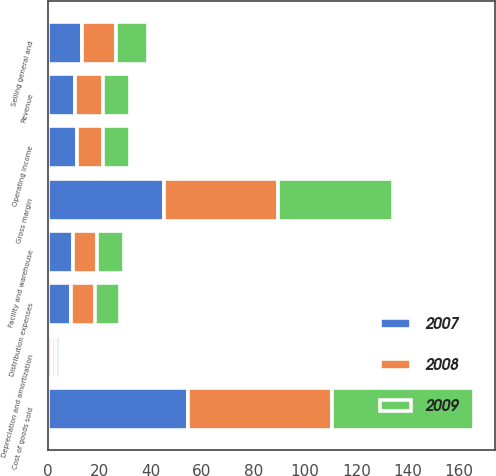<chart> <loc_0><loc_0><loc_500><loc_500><stacked_bar_chart><ecel><fcel>Revenue<fcel>Cost of goods sold<fcel>Gross margin<fcel>Facility and warehouse<fcel>Distribution expenses<fcel>Selling general and<fcel>Depreciation and amortization<fcel>Operating income<nl><fcel>2007<fcel>10.7<fcel>54.7<fcel>45.3<fcel>9.8<fcel>8.9<fcel>13.5<fcel>1.7<fcel>11.3<nl><fcel>2008<fcel>10.7<fcel>55.8<fcel>44.2<fcel>9.5<fcel>9.4<fcel>13.1<fcel>1.6<fcel>10.1<nl><fcel>2009<fcel>10.7<fcel>55.2<fcel>44.8<fcel>10.3<fcel>9.7<fcel>12.6<fcel>1.5<fcel>10.7<nl></chart> 